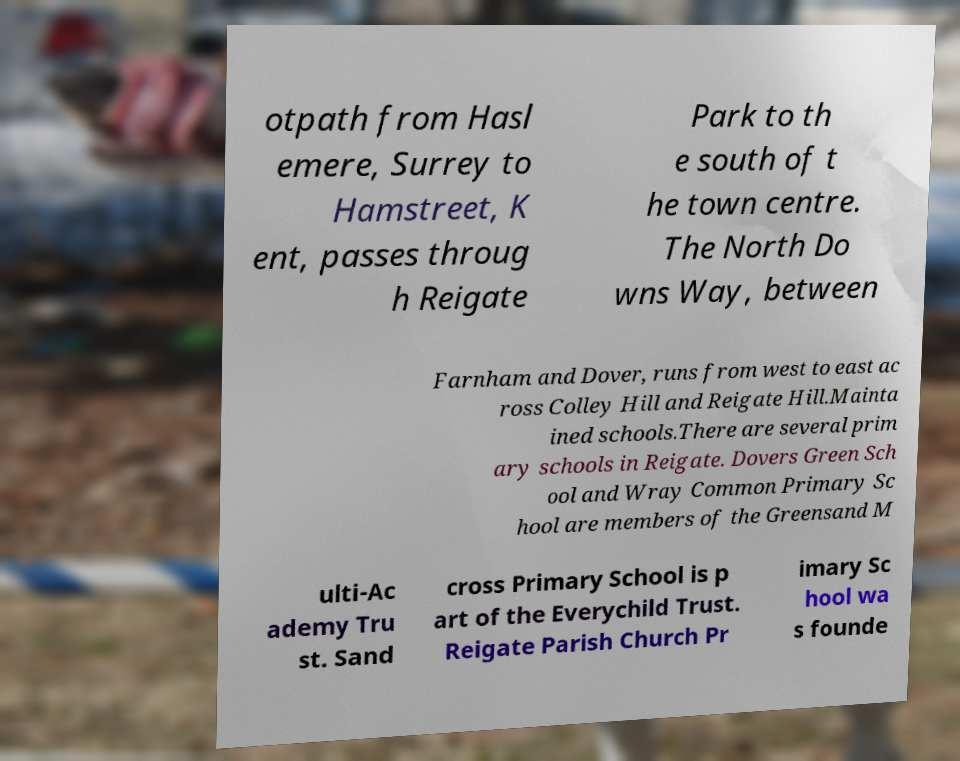For documentation purposes, I need the text within this image transcribed. Could you provide that? otpath from Hasl emere, Surrey to Hamstreet, K ent, passes throug h Reigate Park to th e south of t he town centre. The North Do wns Way, between Farnham and Dover, runs from west to east ac ross Colley Hill and Reigate Hill.Mainta ined schools.There are several prim ary schools in Reigate. Dovers Green Sch ool and Wray Common Primary Sc hool are members of the Greensand M ulti-Ac ademy Tru st. Sand cross Primary School is p art of the Everychild Trust. Reigate Parish Church Pr imary Sc hool wa s founde 